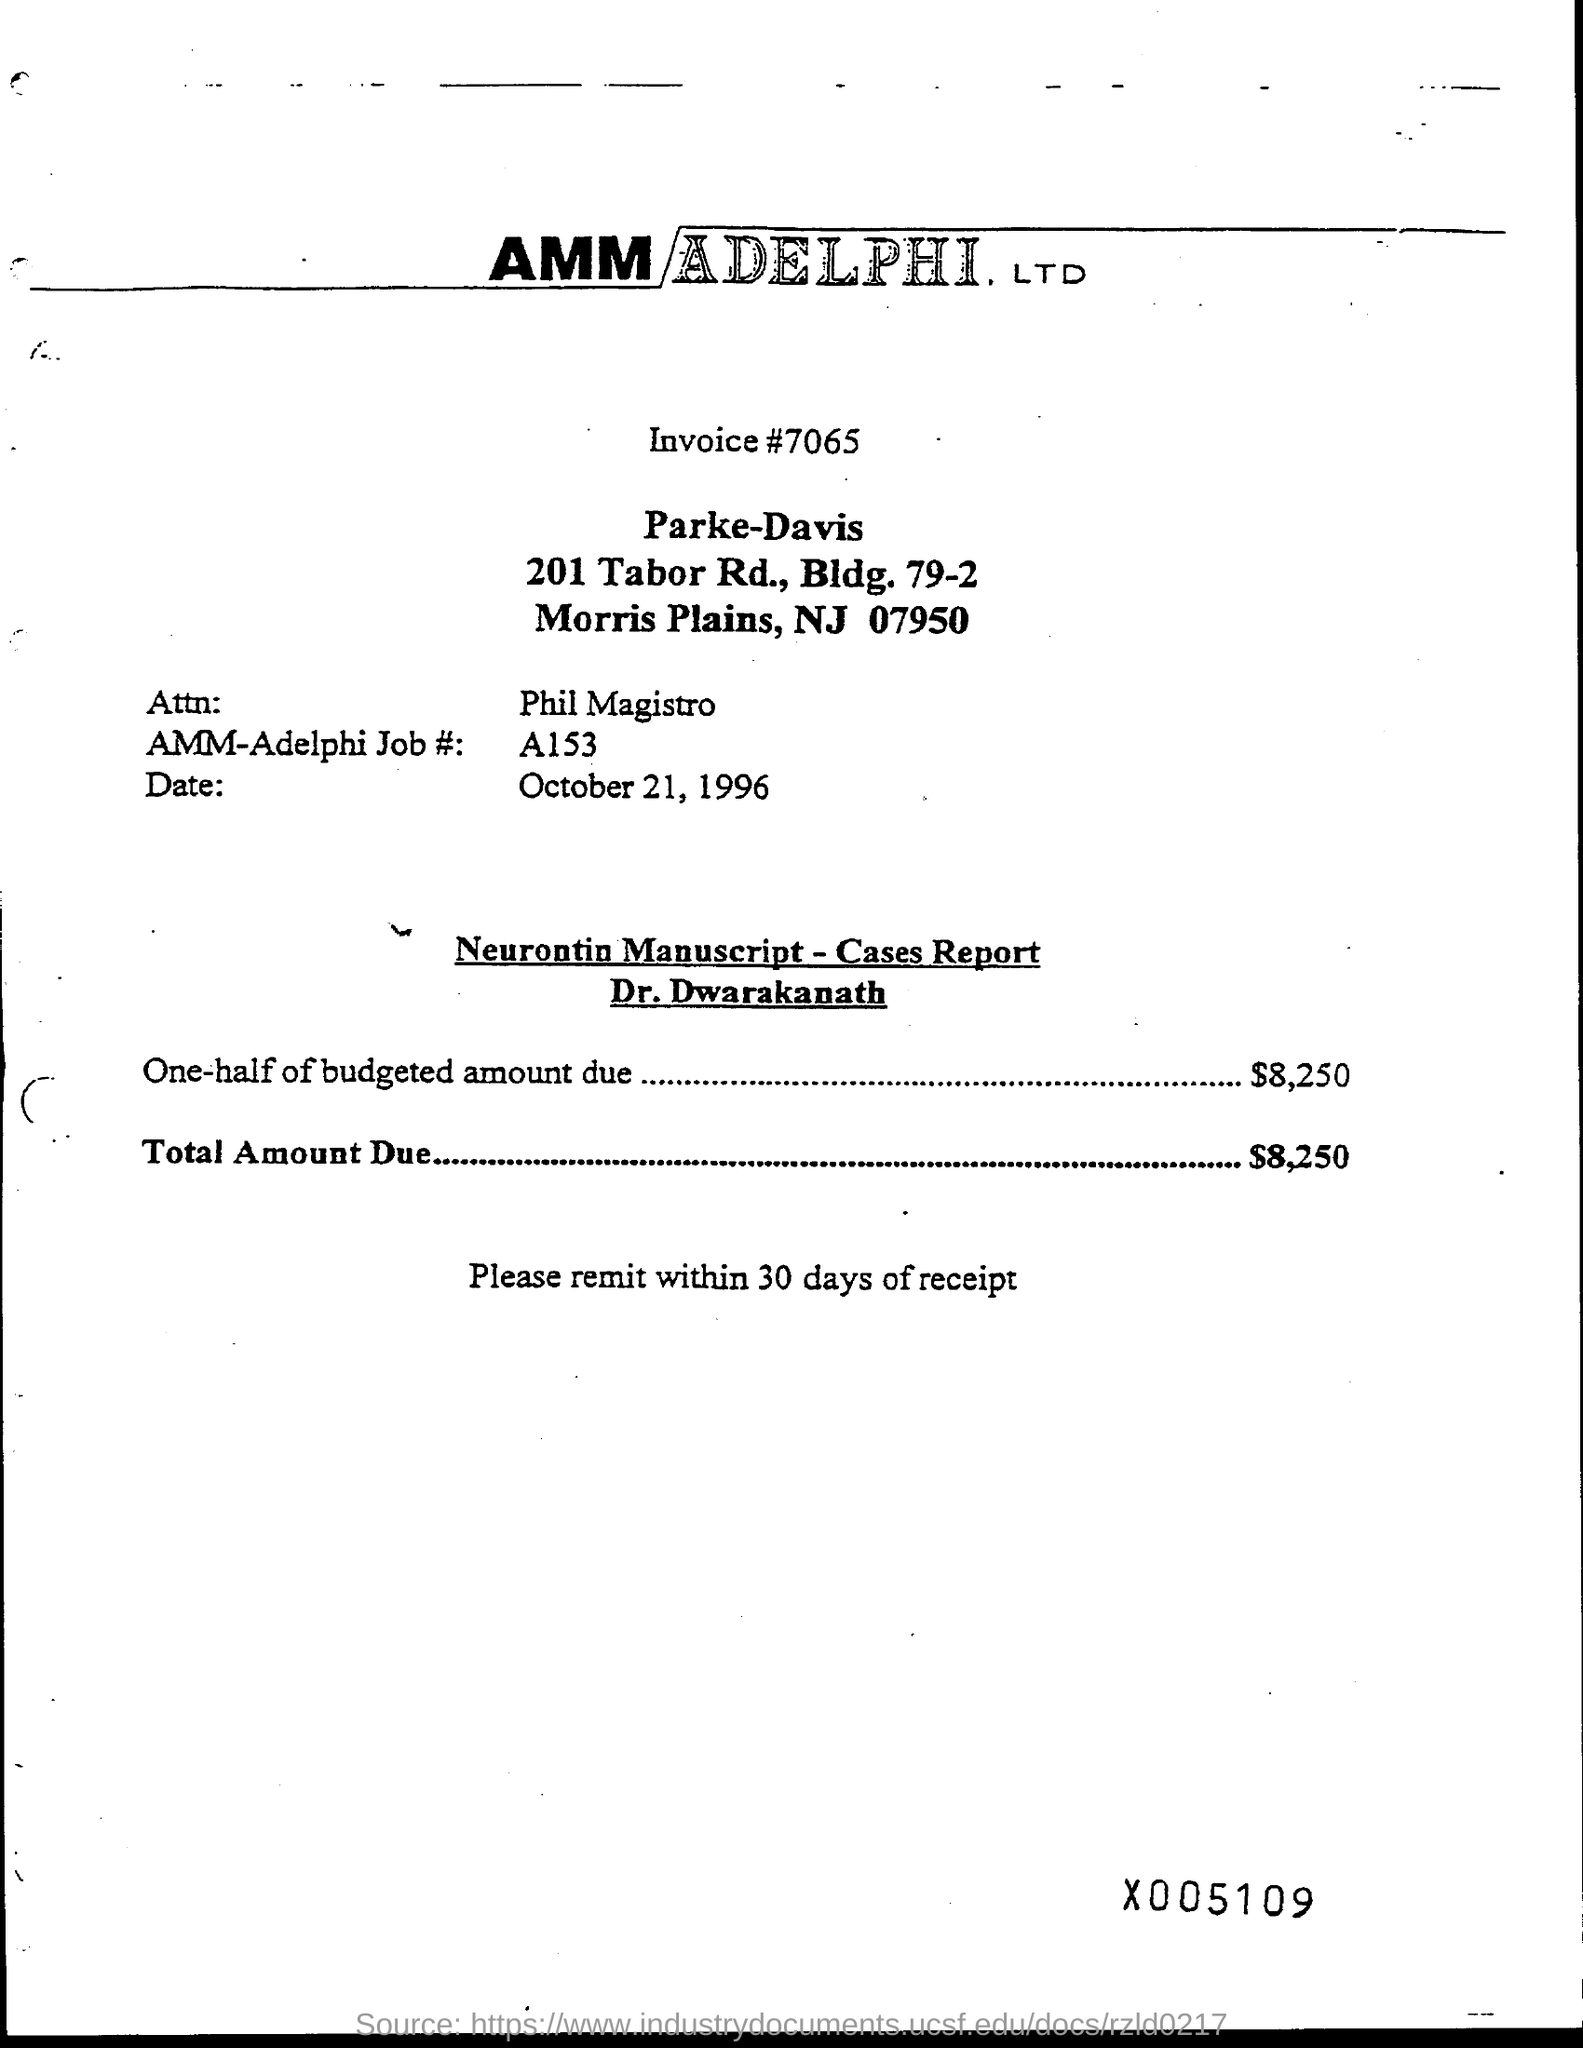What is the date of the invoice given?
Your response must be concise. OCTOBER 21, 1996. What is the Invoice# mentioned in the document?
Offer a terse response. 7065. What is the AMM-Adelphi Job# (no) given in the invoice?
Make the answer very short. A153. What is the one-half of budgeted amount due mentioned in the invoice?
Make the answer very short. $8,250. What is the total amount due mentioned in the invoice?
Ensure brevity in your answer.  $8,250. 